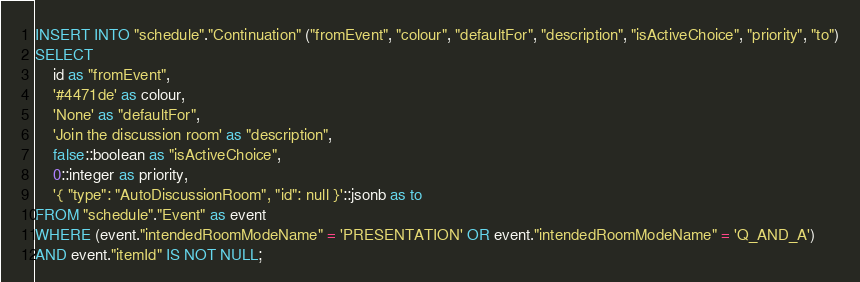<code> <loc_0><loc_0><loc_500><loc_500><_SQL_>INSERT INTO "schedule"."Continuation" ("fromEvent", "colour", "defaultFor", "description", "isActiveChoice", "priority", "to")
SELECT 
    id as "fromEvent",
    '#4471de' as colour,
    'None' as "defaultFor",
    'Join the discussion room' as "description",
    false::boolean as "isActiveChoice",
    0::integer as priority,
    '{ "type": "AutoDiscussionRoom", "id": null }'::jsonb as to
FROM "schedule"."Event" as event
WHERE (event."intendedRoomModeName" = 'PRESENTATION' OR event."intendedRoomModeName" = 'Q_AND_A')
AND event."itemId" IS NOT NULL;
</code> 